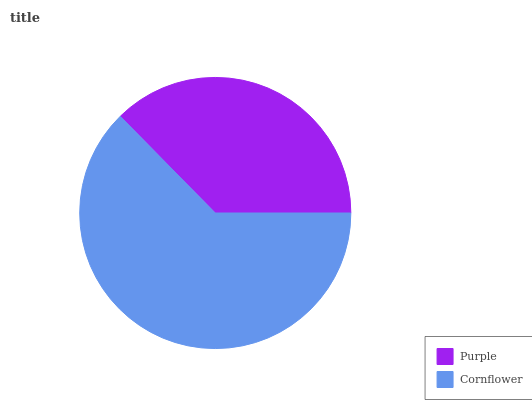Is Purple the minimum?
Answer yes or no. Yes. Is Cornflower the maximum?
Answer yes or no. Yes. Is Cornflower the minimum?
Answer yes or no. No. Is Cornflower greater than Purple?
Answer yes or no. Yes. Is Purple less than Cornflower?
Answer yes or no. Yes. Is Purple greater than Cornflower?
Answer yes or no. No. Is Cornflower less than Purple?
Answer yes or no. No. Is Cornflower the high median?
Answer yes or no. Yes. Is Purple the low median?
Answer yes or no. Yes. Is Purple the high median?
Answer yes or no. No. Is Cornflower the low median?
Answer yes or no. No. 